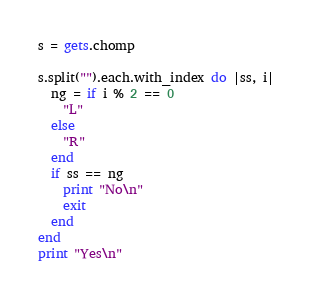Convert code to text. <code><loc_0><loc_0><loc_500><loc_500><_Ruby_>s = gets.chomp

s.split("").each.with_index do |ss, i|
  ng = if i % 2 == 0
    "L"
  else
    "R"
  end
  if ss == ng
    print "No\n"
    exit
  end
end
print "Yes\n"</code> 